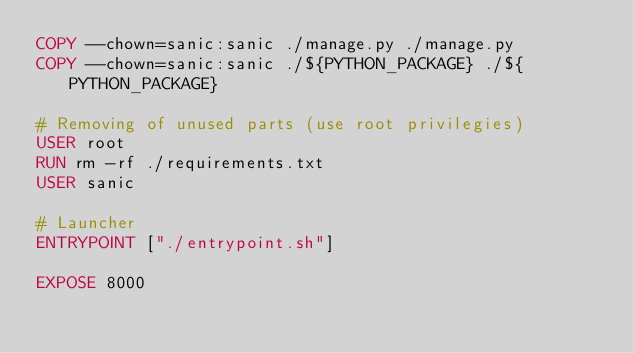<code> <loc_0><loc_0><loc_500><loc_500><_Dockerfile_>COPY --chown=sanic:sanic ./manage.py ./manage.py
COPY --chown=sanic:sanic ./${PYTHON_PACKAGE} ./${PYTHON_PACKAGE}

# Removing of unused parts (use root privilegies)
USER root
RUN rm -rf ./requirements.txt
USER sanic

# Launcher
ENTRYPOINT ["./entrypoint.sh"]

EXPOSE 8000
</code> 